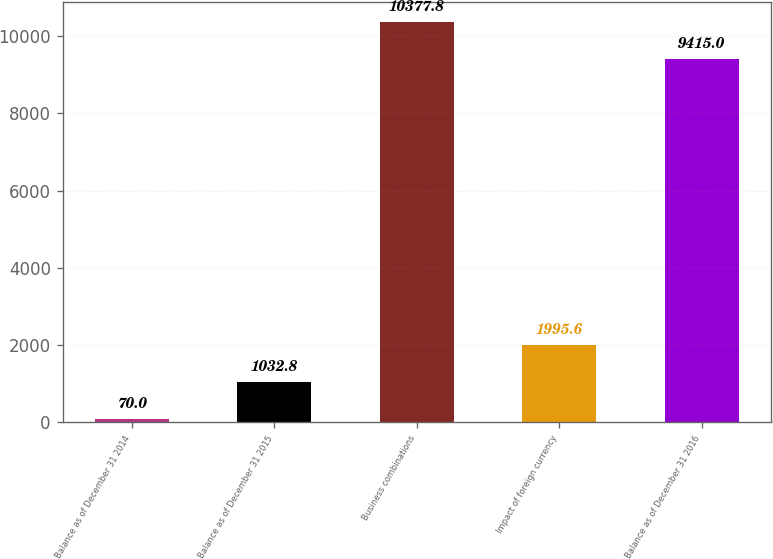Convert chart. <chart><loc_0><loc_0><loc_500><loc_500><bar_chart><fcel>Balance as of December 31 2014<fcel>Balance as of December 31 2015<fcel>Business combinations<fcel>Impact of foreign currency<fcel>Balance as of December 31 2016<nl><fcel>70<fcel>1032.8<fcel>10377.8<fcel>1995.6<fcel>9415<nl></chart> 